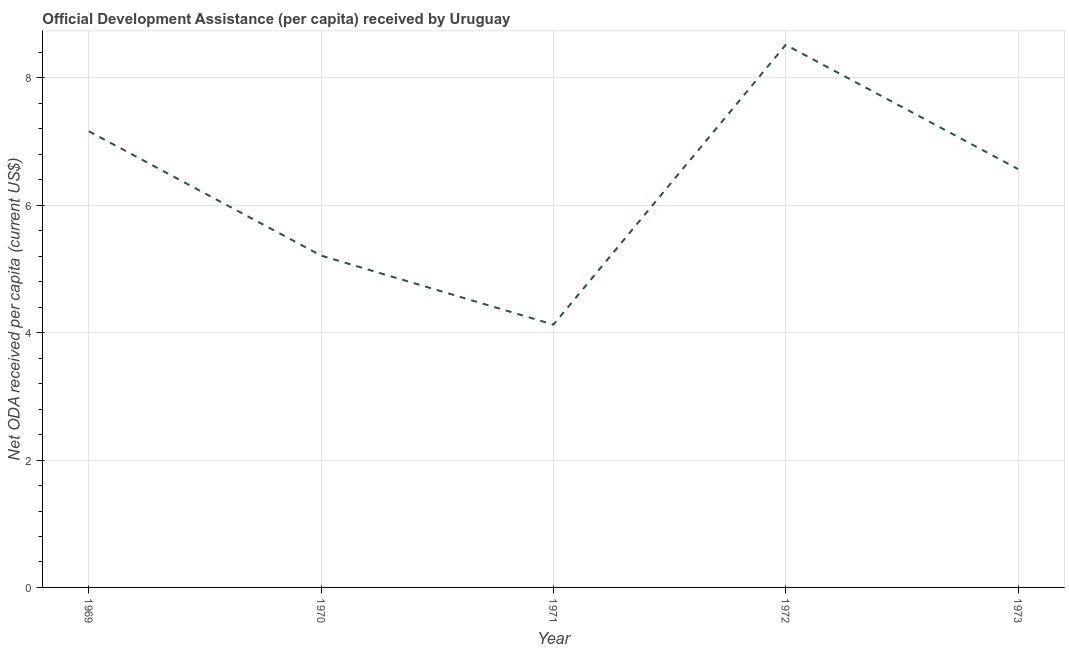What is the net oda received per capita in 1973?
Ensure brevity in your answer.  6.57. Across all years, what is the maximum net oda received per capita?
Provide a short and direct response. 8.52. Across all years, what is the minimum net oda received per capita?
Give a very brief answer. 4.13. In which year was the net oda received per capita maximum?
Your answer should be compact. 1972. In which year was the net oda received per capita minimum?
Keep it short and to the point. 1971. What is the sum of the net oda received per capita?
Offer a terse response. 31.59. What is the difference between the net oda received per capita in 1969 and 1971?
Offer a very short reply. 3.04. What is the average net oda received per capita per year?
Keep it short and to the point. 6.32. What is the median net oda received per capita?
Provide a succinct answer. 6.57. In how many years, is the net oda received per capita greater than 1.2000000000000002 US$?
Keep it short and to the point. 5. What is the ratio of the net oda received per capita in 1969 to that in 1971?
Keep it short and to the point. 1.74. Is the difference between the net oda received per capita in 1969 and 1972 greater than the difference between any two years?
Your response must be concise. No. What is the difference between the highest and the second highest net oda received per capita?
Your answer should be very brief. 1.36. Is the sum of the net oda received per capita in 1970 and 1971 greater than the maximum net oda received per capita across all years?
Ensure brevity in your answer.  Yes. What is the difference between the highest and the lowest net oda received per capita?
Provide a short and direct response. 4.39. In how many years, is the net oda received per capita greater than the average net oda received per capita taken over all years?
Make the answer very short. 3. Does the net oda received per capita monotonically increase over the years?
Offer a very short reply. No. Are the values on the major ticks of Y-axis written in scientific E-notation?
Your answer should be compact. No. Does the graph contain grids?
Your response must be concise. Yes. What is the title of the graph?
Your answer should be compact. Official Development Assistance (per capita) received by Uruguay. What is the label or title of the Y-axis?
Make the answer very short. Net ODA received per capita (current US$). What is the Net ODA received per capita (current US$) of 1969?
Ensure brevity in your answer.  7.16. What is the Net ODA received per capita (current US$) of 1970?
Your answer should be very brief. 5.21. What is the Net ODA received per capita (current US$) of 1971?
Offer a very short reply. 4.13. What is the Net ODA received per capita (current US$) in 1972?
Provide a succinct answer. 8.52. What is the Net ODA received per capita (current US$) of 1973?
Offer a terse response. 6.57. What is the difference between the Net ODA received per capita (current US$) in 1969 and 1970?
Make the answer very short. 1.95. What is the difference between the Net ODA received per capita (current US$) in 1969 and 1971?
Your answer should be compact. 3.04. What is the difference between the Net ODA received per capita (current US$) in 1969 and 1972?
Provide a succinct answer. -1.36. What is the difference between the Net ODA received per capita (current US$) in 1969 and 1973?
Provide a succinct answer. 0.59. What is the difference between the Net ODA received per capita (current US$) in 1970 and 1971?
Make the answer very short. 1.08. What is the difference between the Net ODA received per capita (current US$) in 1970 and 1972?
Keep it short and to the point. -3.31. What is the difference between the Net ODA received per capita (current US$) in 1970 and 1973?
Make the answer very short. -1.36. What is the difference between the Net ODA received per capita (current US$) in 1971 and 1972?
Keep it short and to the point. -4.39. What is the difference between the Net ODA received per capita (current US$) in 1971 and 1973?
Your response must be concise. -2.44. What is the difference between the Net ODA received per capita (current US$) in 1972 and 1973?
Offer a very short reply. 1.95. What is the ratio of the Net ODA received per capita (current US$) in 1969 to that in 1970?
Provide a short and direct response. 1.38. What is the ratio of the Net ODA received per capita (current US$) in 1969 to that in 1971?
Provide a succinct answer. 1.74. What is the ratio of the Net ODA received per capita (current US$) in 1969 to that in 1972?
Your response must be concise. 0.84. What is the ratio of the Net ODA received per capita (current US$) in 1969 to that in 1973?
Make the answer very short. 1.09. What is the ratio of the Net ODA received per capita (current US$) in 1970 to that in 1971?
Provide a short and direct response. 1.26. What is the ratio of the Net ODA received per capita (current US$) in 1970 to that in 1972?
Your response must be concise. 0.61. What is the ratio of the Net ODA received per capita (current US$) in 1970 to that in 1973?
Your response must be concise. 0.79. What is the ratio of the Net ODA received per capita (current US$) in 1971 to that in 1972?
Keep it short and to the point. 0.48. What is the ratio of the Net ODA received per capita (current US$) in 1971 to that in 1973?
Provide a short and direct response. 0.63. What is the ratio of the Net ODA received per capita (current US$) in 1972 to that in 1973?
Offer a very short reply. 1.3. 